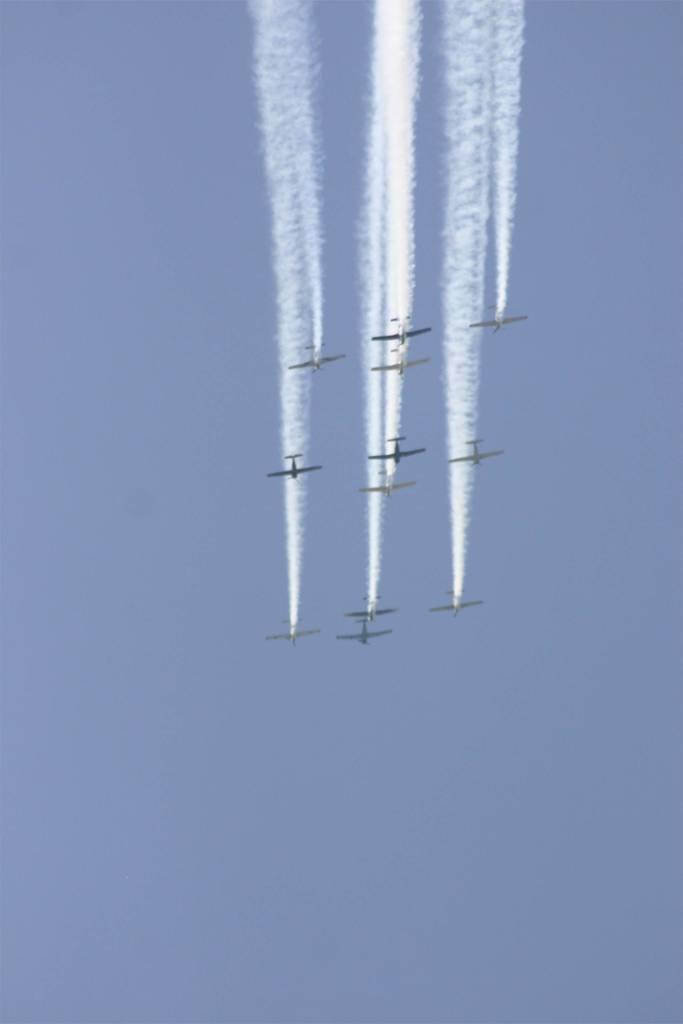What is happening in the image? There are airplanes flying in the image. What can be seen coming from the airplanes? White color smoke is visible in the image. What is visible in the background of the image? The sky is visible in the image. What type of protest is taking place in the image? There is no protest present in the image; it features airplanes flying and emitting white color smoke. Can you see any wounds on the airplanes in the image? There are no wounds visible on the airplanes in the image. 